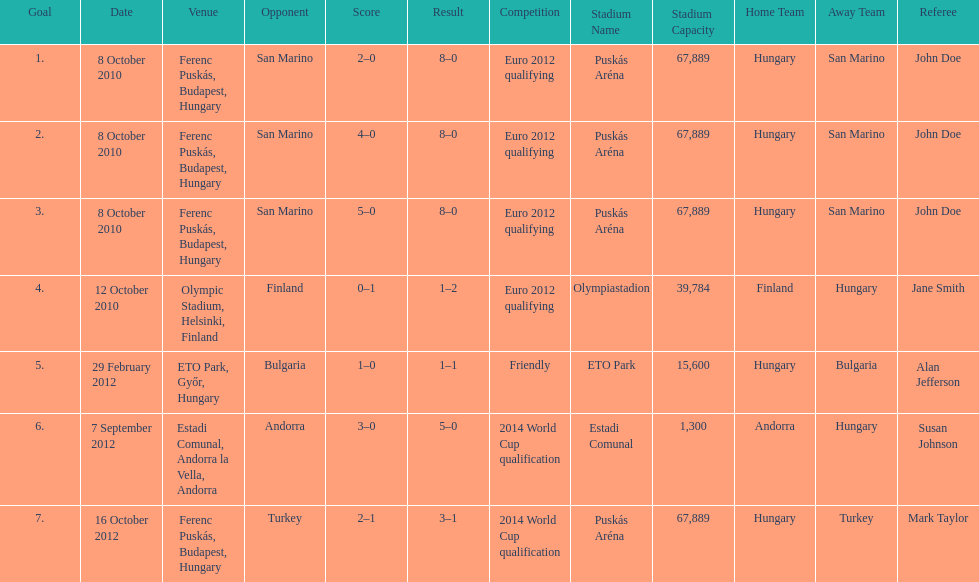Szalai scored all but one of his international goals in either euro 2012 qualifying or what other level of play? 2014 World Cup qualification. 